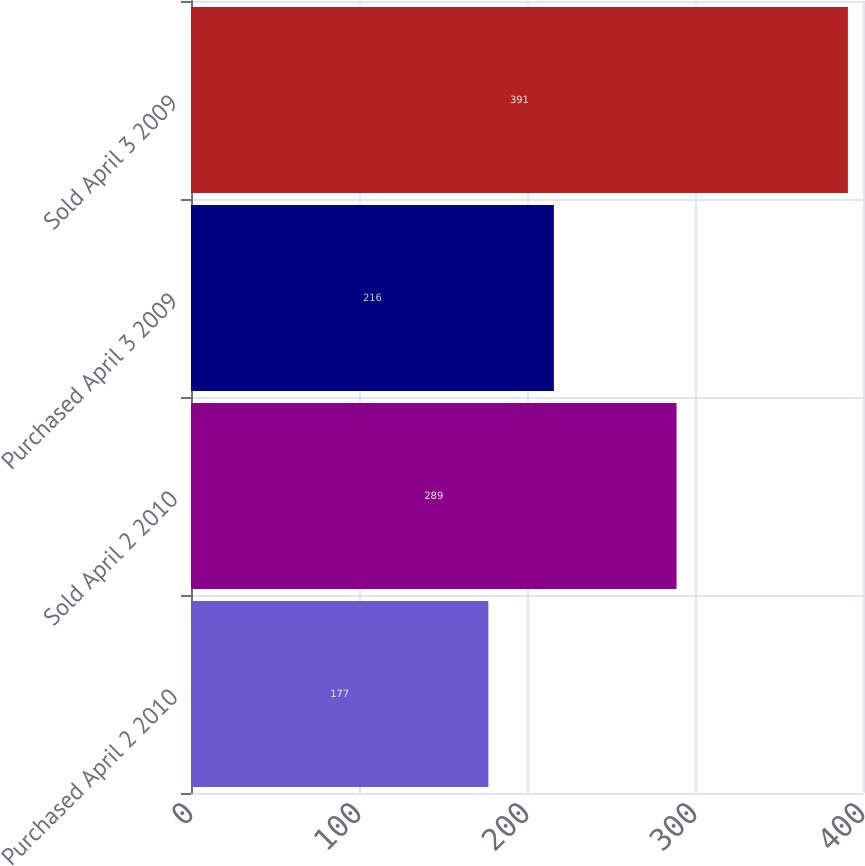Convert chart to OTSL. <chart><loc_0><loc_0><loc_500><loc_500><bar_chart><fcel>Purchased April 2 2010<fcel>Sold April 2 2010<fcel>Purchased April 3 2009<fcel>Sold April 3 2009<nl><fcel>177<fcel>289<fcel>216<fcel>391<nl></chart> 